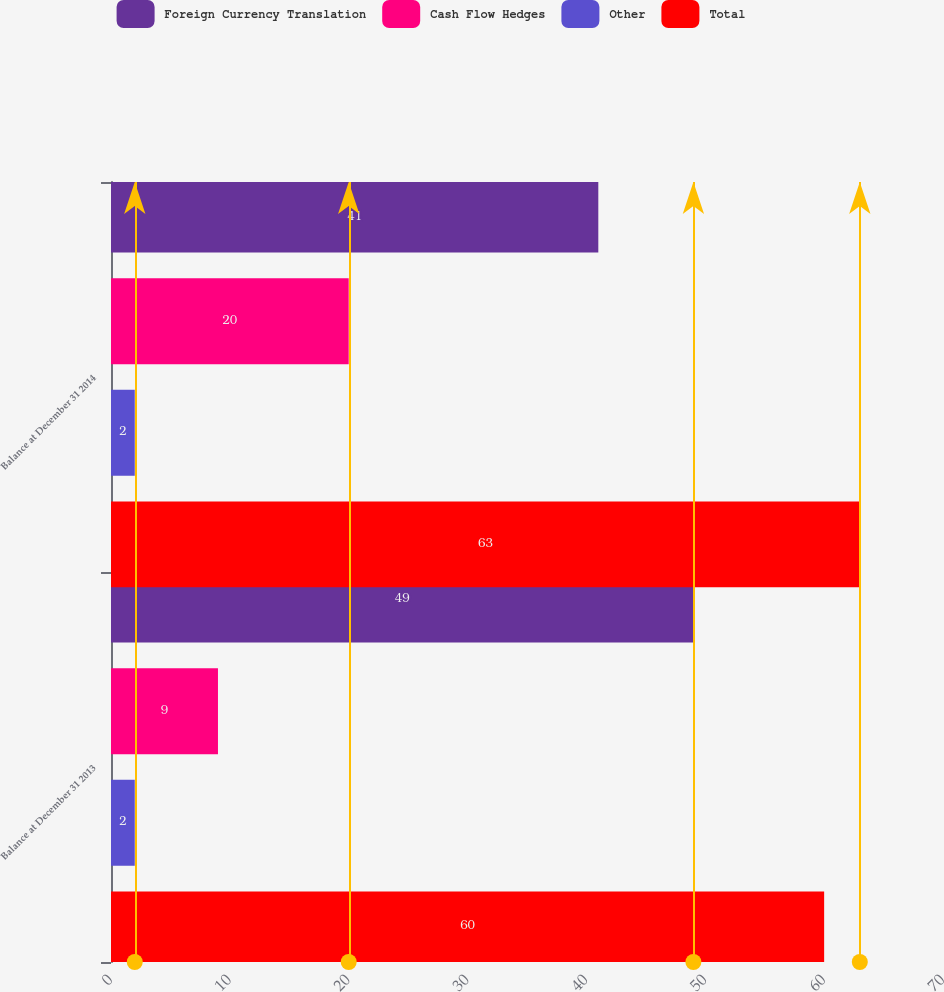Convert chart to OTSL. <chart><loc_0><loc_0><loc_500><loc_500><stacked_bar_chart><ecel><fcel>Balance at December 31 2013<fcel>Balance at December 31 2014<nl><fcel>Foreign Currency Translation<fcel>49<fcel>41<nl><fcel>Cash Flow Hedges<fcel>9<fcel>20<nl><fcel>Other<fcel>2<fcel>2<nl><fcel>Total<fcel>60<fcel>63<nl></chart> 